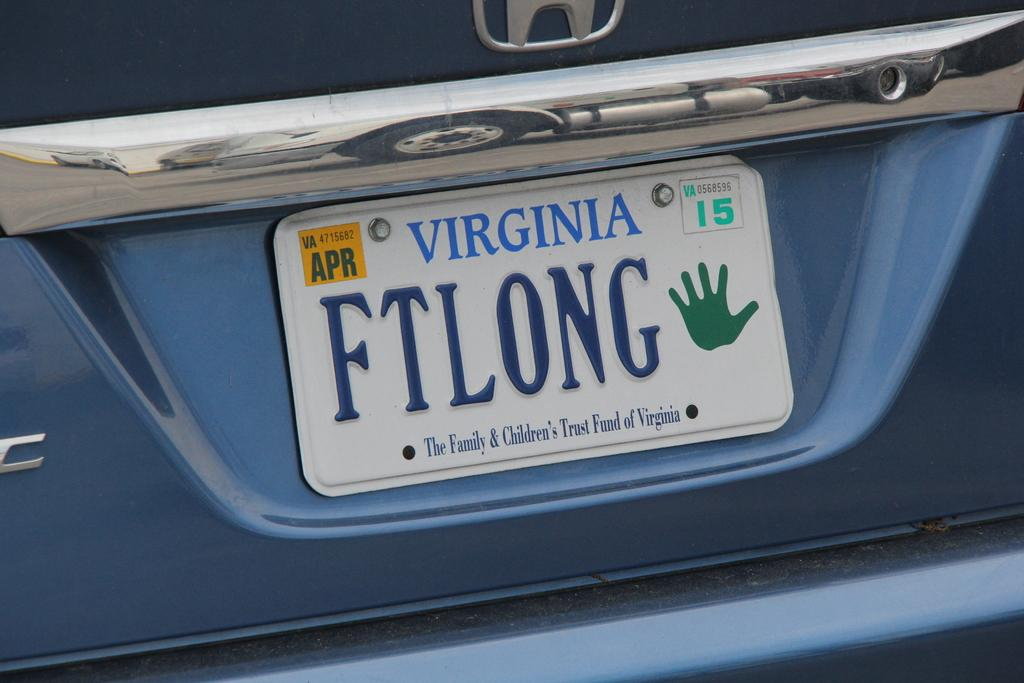<image>
Relay a brief, clear account of the picture shown. License plate of a car in Virginia that expires in April. 